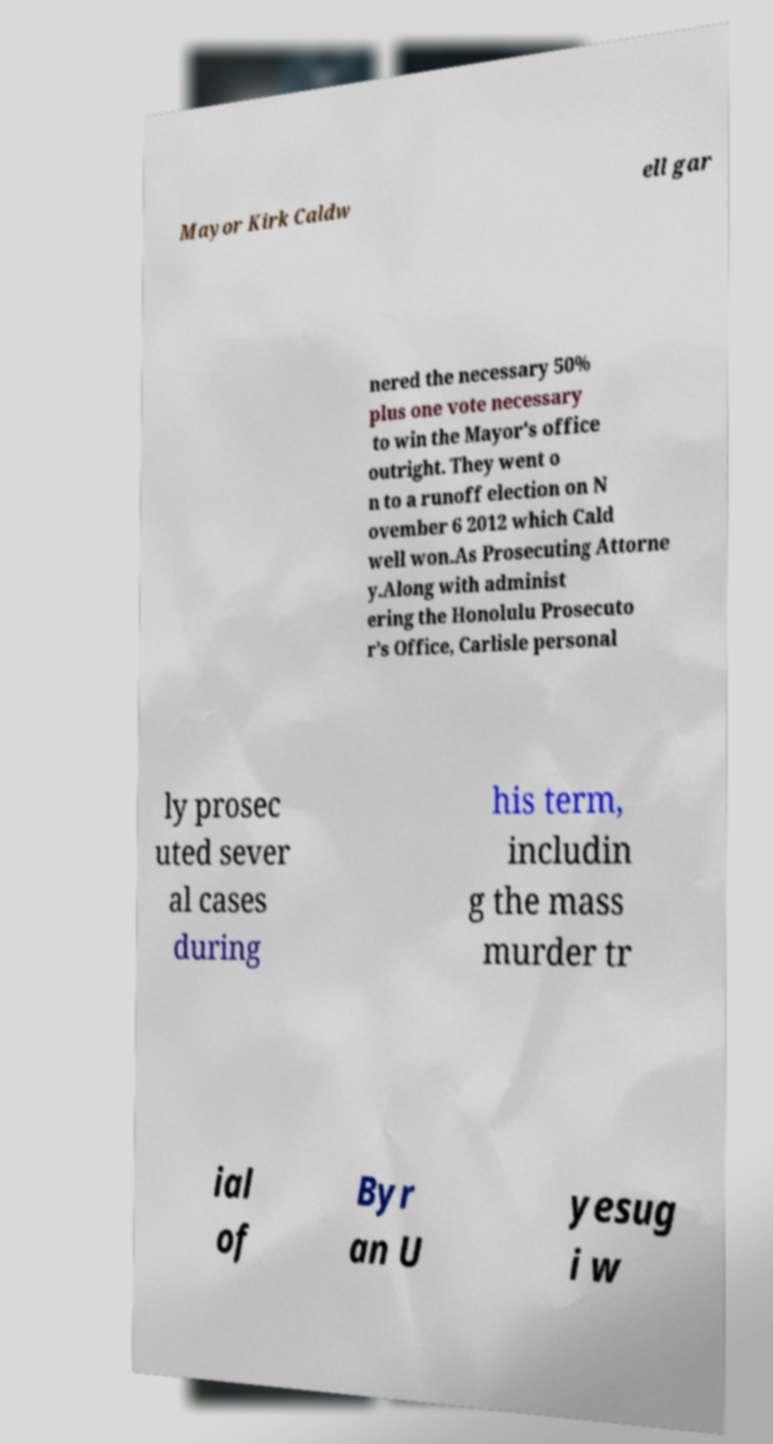Please read and relay the text visible in this image. What does it say? Mayor Kirk Caldw ell gar nered the necessary 50% plus one vote necessary to win the Mayor's office outright. They went o n to a runoff election on N ovember 6 2012 which Cald well won.As Prosecuting Attorne y.Along with administ ering the Honolulu Prosecuto r’s Office, Carlisle personal ly prosec uted sever al cases during his term, includin g the mass murder tr ial of Byr an U yesug i w 